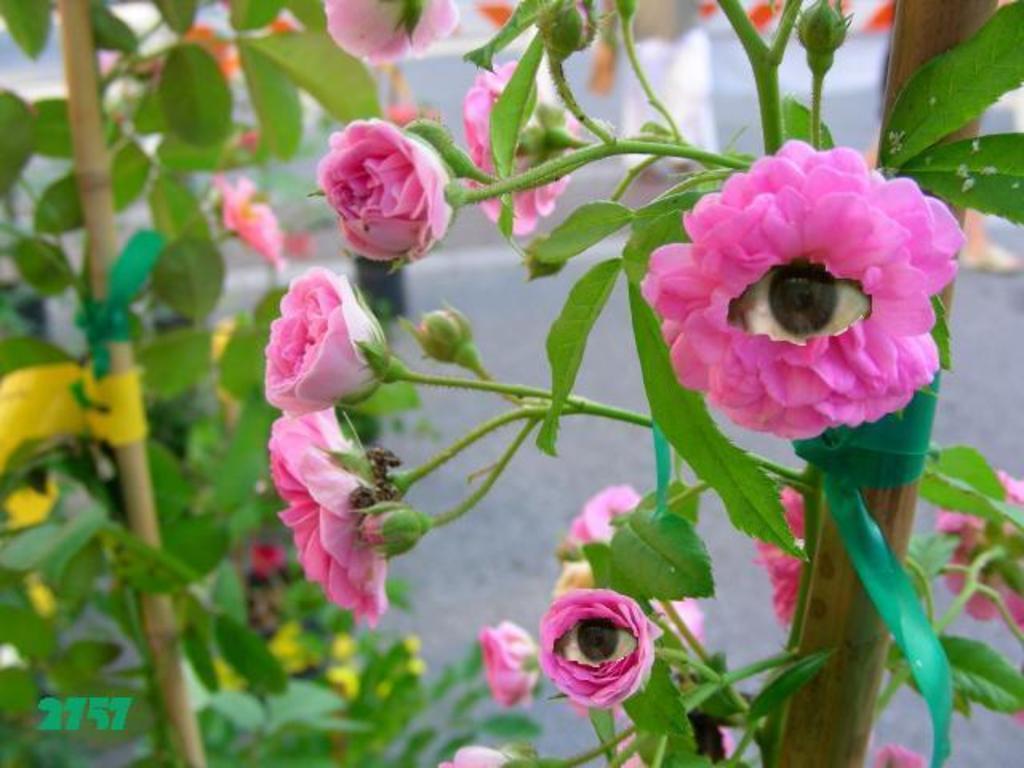Could you give a brief overview of what you see in this image? This image is taken outdoors. In the background there is a wall. In the middle of the image there are a few plants with green leaves. On the right side of the image there is a plant with a few pink roses and buds. 